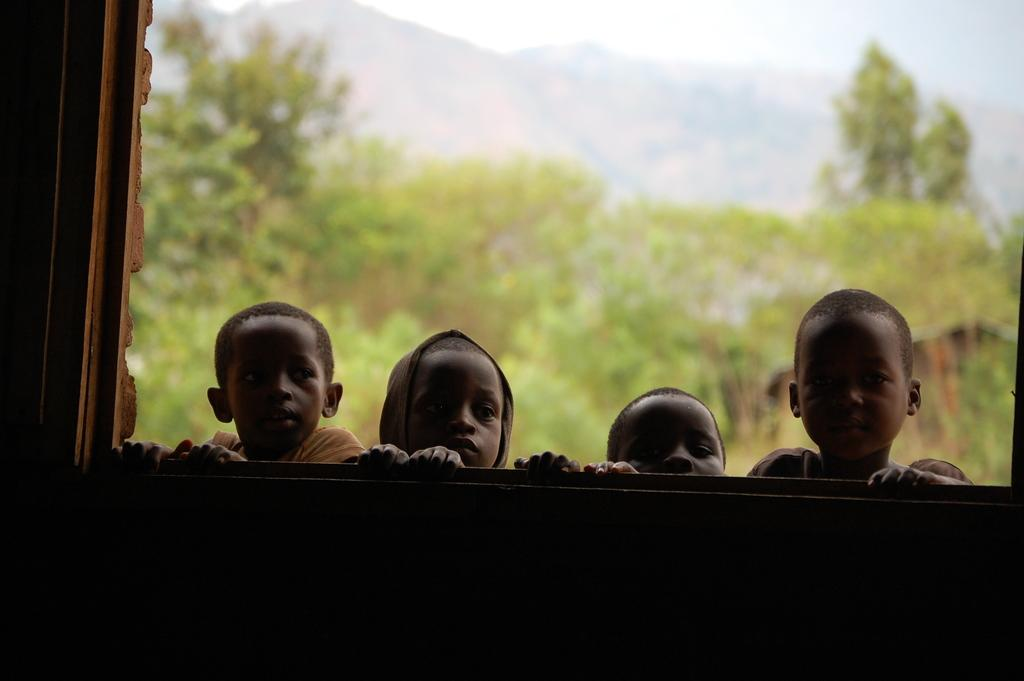What is the main subject of the image? The main subject of the image is a group of boys standing. What can be seen in the background of the image? There is a window, trees, mountains, and the sky visible in the image. What type of bomb can be seen in the image? There is no bomb present in the image. Are the boys in the image crying? The emotions of the boys cannot be determined from the image, so it cannot be said whether they are crying or not. 